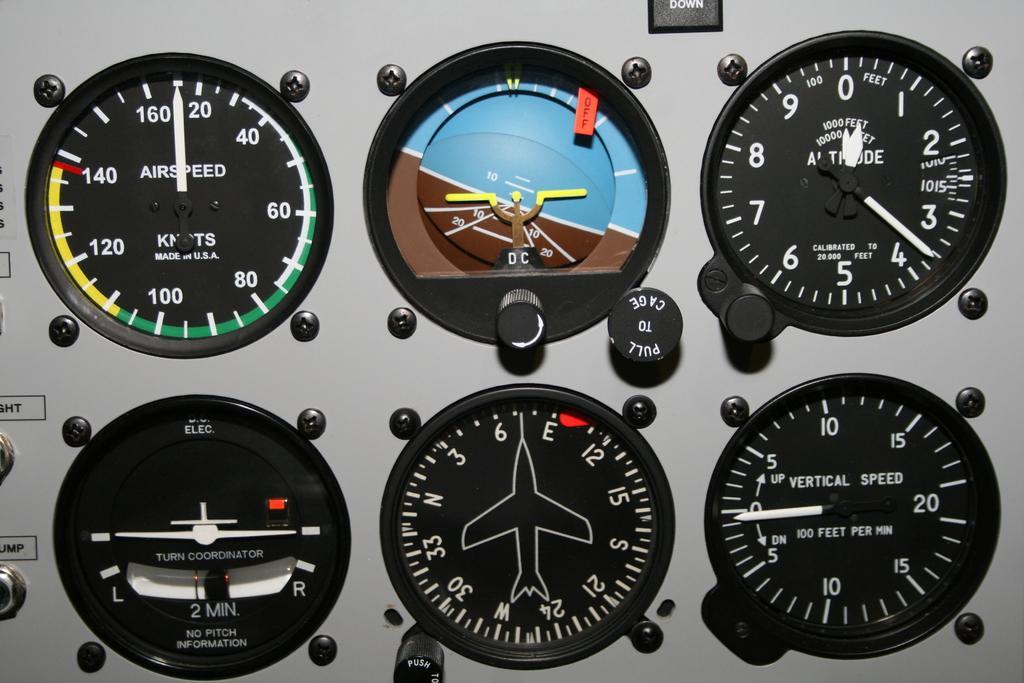Please provide a concise description of this image. In this picture I can see there is a speedometer and and it has some numerical reading and it has some indicators in white color and there are few nuts here. 